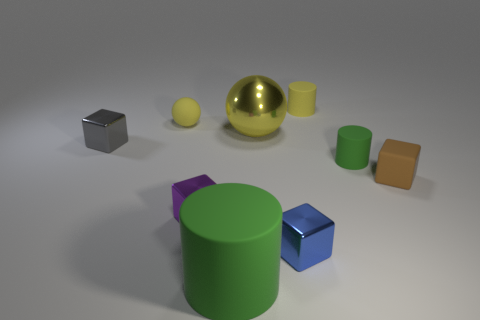What can you infer about the lighting in this scene? The lighting in this scene appears to be diffused and coming from above, as evidenced by the soft shadows cast by the objects on the ground. The reflective surfaces like the golden sphere and the blue cube are highlighting the light source’s position due to their bright reflections. 